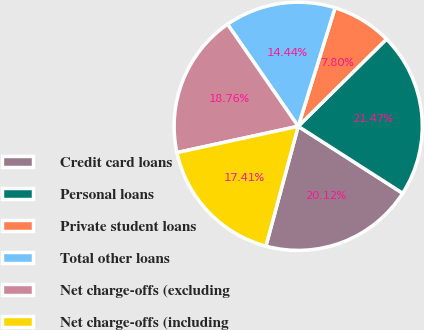Convert chart. <chart><loc_0><loc_0><loc_500><loc_500><pie_chart><fcel>Credit card loans<fcel>Personal loans<fcel>Private student loans<fcel>Total other loans<fcel>Net charge-offs (excluding<fcel>Net charge-offs (including<nl><fcel>20.12%<fcel>21.47%<fcel>7.8%<fcel>14.44%<fcel>18.76%<fcel>17.41%<nl></chart> 